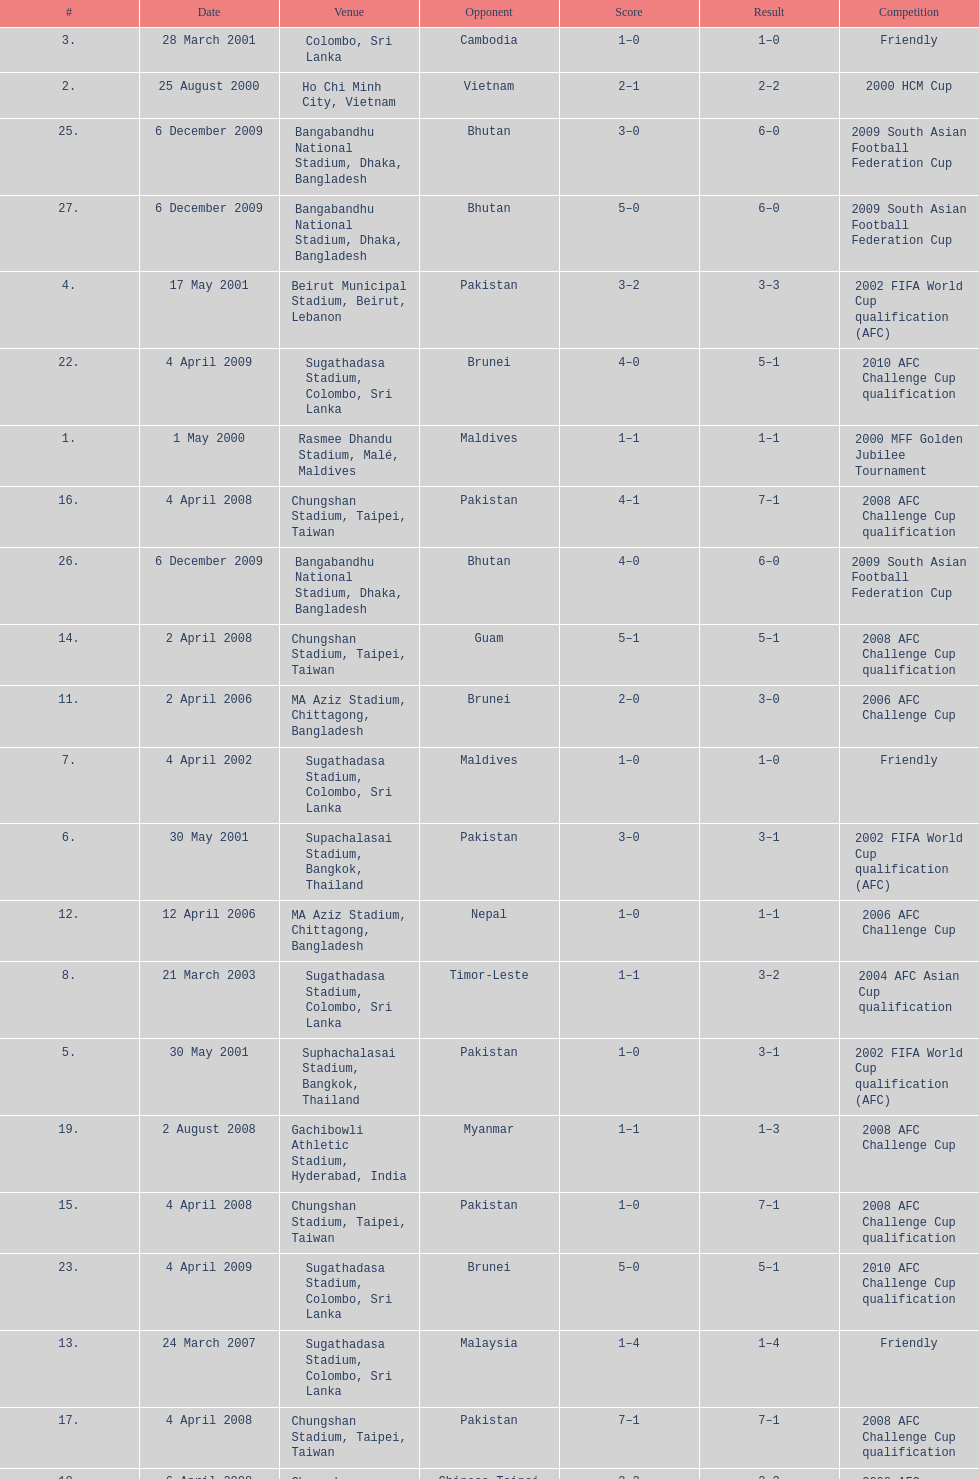What was the total number of goals score in the sri lanka - malaysia game of march 24, 2007? 5. 